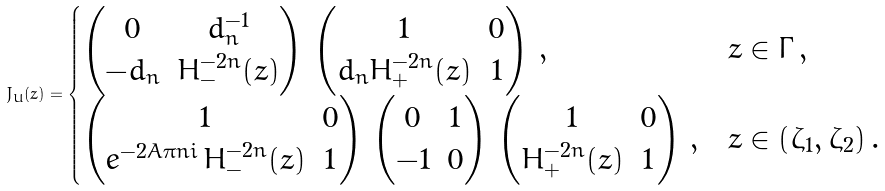Convert formula to latex. <formula><loc_0><loc_0><loc_500><loc_500>J _ { U } ( z ) = \begin{cases} \begin{pmatrix} 0 & d _ { n } ^ { - 1 } \\ - d _ { n } & H _ { - } ^ { - 2 n } ( z ) \end{pmatrix} \, \begin{pmatrix} 1 & 0 \\ d _ { n } H _ { + } ^ { - 2 n } ( z ) & 1 \end{pmatrix} \, , & z \in \Gamma \, , \\ \begin{pmatrix} 1 & 0 \\ e ^ { - 2 A \pi n i } \, H _ { - } ^ { - 2 n } ( z ) & 1 \end{pmatrix} \, \begin{pmatrix} 0 & 1 \\ - 1 & 0 \end{pmatrix} \, \begin{pmatrix} 1 & 0 \\ H _ { + } ^ { - 2 n } ( z ) & 1 \end{pmatrix} \, , & z \in ( \zeta _ { 1 } , \zeta _ { 2 } ) \, . \end{cases}</formula> 